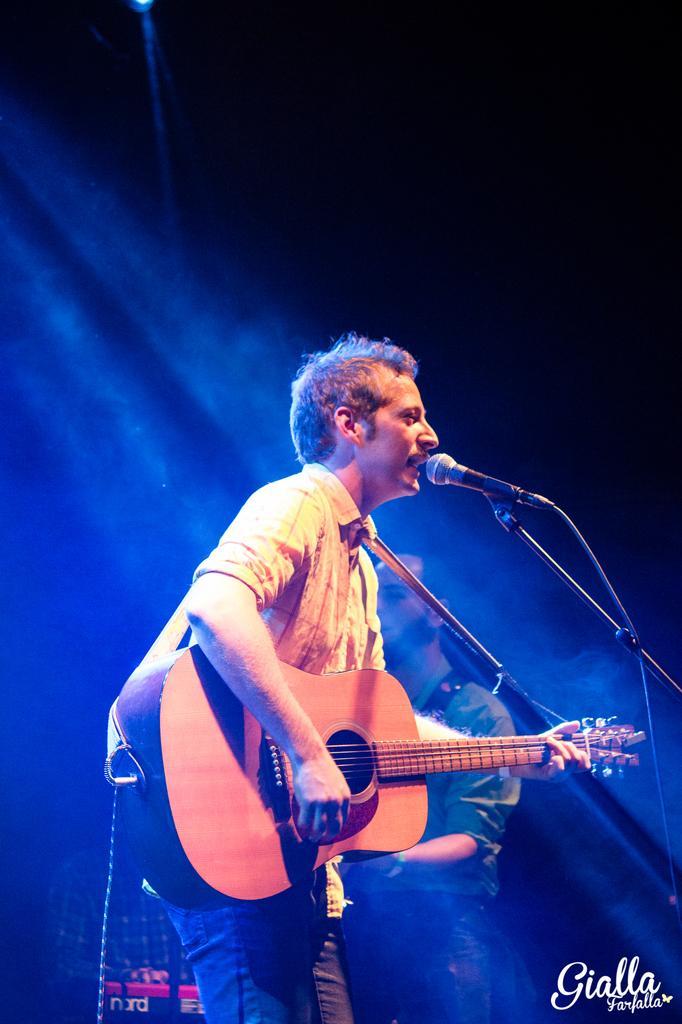How would you summarize this image in a sentence or two? In the middle of the image a man is standing and playing guitar and singing. Behind him there is a man standing. 